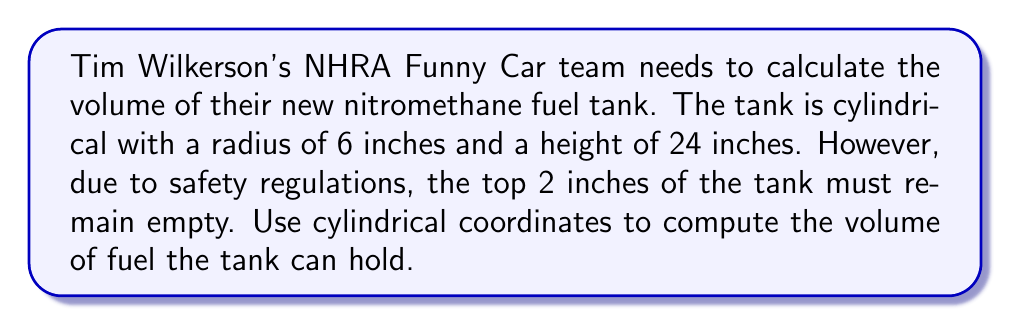What is the answer to this math problem? To solve this problem, we'll use cylindrical coordinates and follow these steps:

1) In cylindrical coordinates, the volume is given by the triple integral:

   $$V = \int_0^{2\pi} \int_0^r \int_a^b \rho \, dz \, d\rho \, d\theta$$

   where $r$ is the radius, $a$ is the lower bound of $z$, and $b$ is the upper bound of $z$.

2) Given:
   - Radius (r) = 6 inches
   - Total height = 24 inches
   - Top 2 inches must remain empty

3) Set up the integral:
   - $\theta$ goes from 0 to $2\pi$
   - $\rho$ goes from 0 to 6
   - $z$ goes from 0 to 22 (since the top 2 inches are empty)

   $$V = \int_0^{2\pi} \int_0^6 \int_0^{22} \rho \, dz \, d\rho \, d\theta$$

4) Solve the integral:

   $$\begin{align}
   V &= \int_0^{2\pi} \int_0^6 \int_0^{22} \rho \, dz \, d\rho \, d\theta \\
   &= \int_0^{2\pi} \int_0^6 \rho [z]_0^{22} \, d\rho \, d\theta \\
   &= \int_0^{2\pi} \int_0^6 22\rho \, d\rho \, d\theta \\
   &= \int_0^{2\pi} 22 [\frac{\rho^2}{2}]_0^6 \, d\theta \\
   &= \int_0^{2\pi} 22 (\frac{36}{2}) \, d\theta \\
   &= \int_0^{2\pi} 396 \, d\theta \\
   &= 396 [θ]_0^{2\pi} \\
   &= 396 (2\pi - 0) \\
   &= 792\pi
   \end{align}$$

5) Convert cubic inches to cubic feet:
   $$792\pi \text{ in}^3 \times \frac{1 \text{ ft}^3}{1728 \text{ in}^3} = \frac{11\pi}{24} \text{ ft}^3 \approx 1.44 \text{ ft}^3$$

Therefore, the volume of fuel the tank can hold is $792\pi$ cubic inches or approximately 1.44 cubic feet.
Answer: $792\pi$ cubic inches or approximately 1.44 cubic feet 